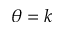Convert formula to latex. <formula><loc_0><loc_0><loc_500><loc_500>\theta = k</formula> 